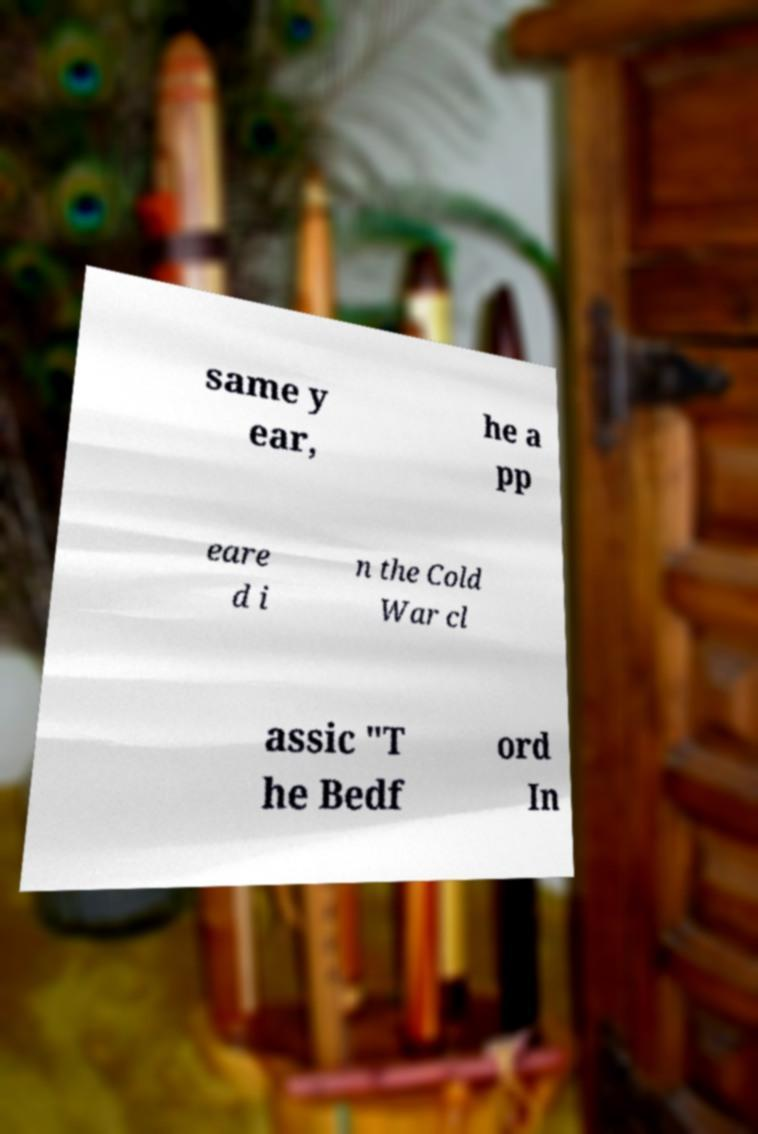Can you accurately transcribe the text from the provided image for me? same y ear, he a pp eare d i n the Cold War cl assic "T he Bedf ord In 